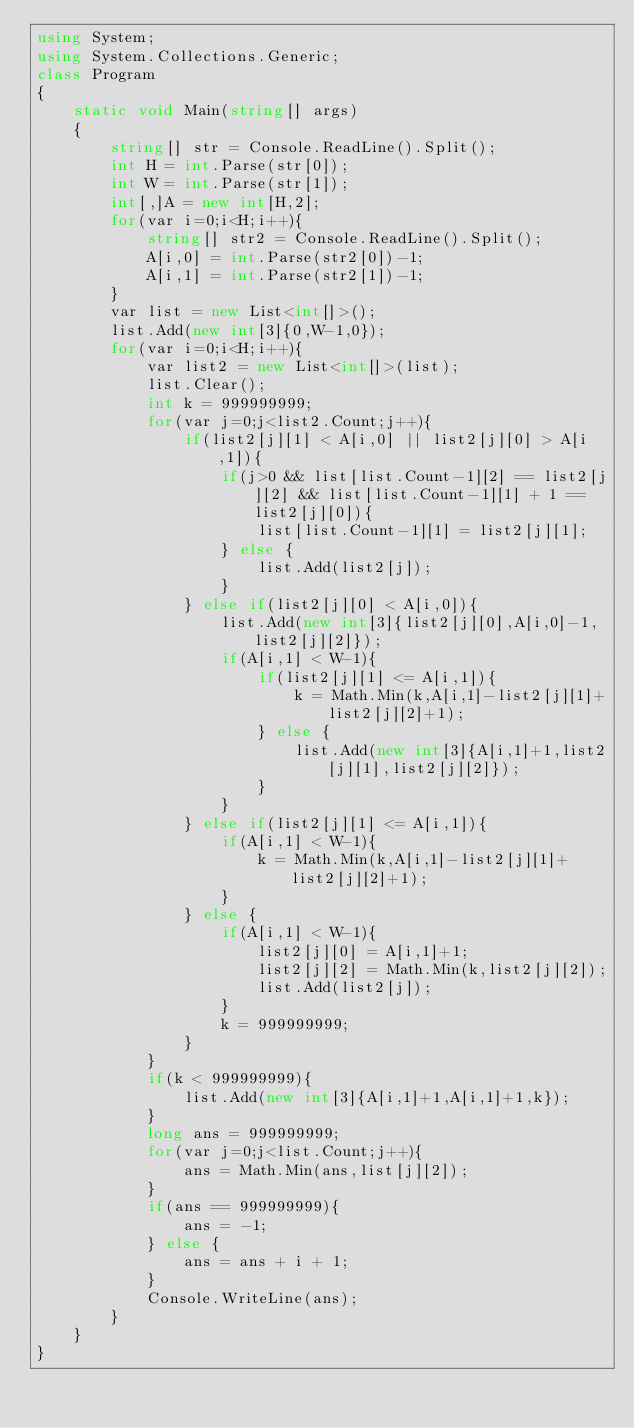Convert code to text. <code><loc_0><loc_0><loc_500><loc_500><_C#_>using System;
using System.Collections.Generic;
class Program
{
	static void Main(string[] args)
	{
		string[] str = Console.ReadLine().Split();
		int H = int.Parse(str[0]);
		int W = int.Parse(str[1]);
		int[,]A = new int[H,2];
		for(var i=0;i<H;i++){
			string[] str2 = Console.ReadLine().Split();
			A[i,0] = int.Parse(str2[0])-1;
			A[i,1] = int.Parse(str2[1])-1;
		}
		var list = new List<int[]>();
		list.Add(new int[3]{0,W-1,0});
		for(var i=0;i<H;i++){
			var list2 = new List<int[]>(list);
			list.Clear();
			int k = 999999999;
			for(var j=0;j<list2.Count;j++){
				if(list2[j][1] < A[i,0] || list2[j][0] > A[i,1]){
					if(j>0 && list[list.Count-1][2] == list2[j][2] && list[list.Count-1][1] + 1 == list2[j][0]){
						list[list.Count-1][1] = list2[j][1];
					} else {
						list.Add(list2[j]);
					}
				} else if(list2[j][0] < A[i,0]){
					list.Add(new int[3]{list2[j][0],A[i,0]-1,list2[j][2]});
					if(A[i,1] < W-1){
						if(list2[j][1] <= A[i,1]){
							k = Math.Min(k,A[i,1]-list2[j][1]+list2[j][2]+1);
						} else {
							list.Add(new int[3]{A[i,1]+1,list2[j][1],list2[j][2]});
						}
					}
				} else if(list2[j][1] <= A[i,1]){
					if(A[i,1] < W-1){
						k = Math.Min(k,A[i,1]-list2[j][1]+list2[j][2]+1);
					}
				} else {
					if(A[i,1] < W-1){
						list2[j][0] = A[i,1]+1;
						list2[j][2] = Math.Min(k,list2[j][2]);
						list.Add(list2[j]);
					}
					k = 999999999;
				}
			}
			if(k < 999999999){
				list.Add(new int[3]{A[i,1]+1,A[i,1]+1,k});
			}
			long ans = 999999999;
			for(var j=0;j<list.Count;j++){
				ans = Math.Min(ans,list[j][2]);
			}
			if(ans == 999999999){
				ans = -1;
			} else {
				ans = ans + i + 1;
			}
			Console.WriteLine(ans);
		}
	}
}</code> 